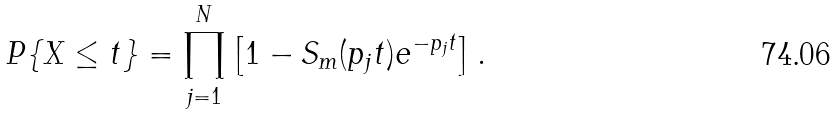Convert formula to latex. <formula><loc_0><loc_0><loc_500><loc_500>P \{ X \leq t \} = \prod _ { j = 1 } ^ { N } \left [ 1 - S _ { m } ( p _ { j } t ) e ^ { - p _ { j } t } \right ] .</formula> 